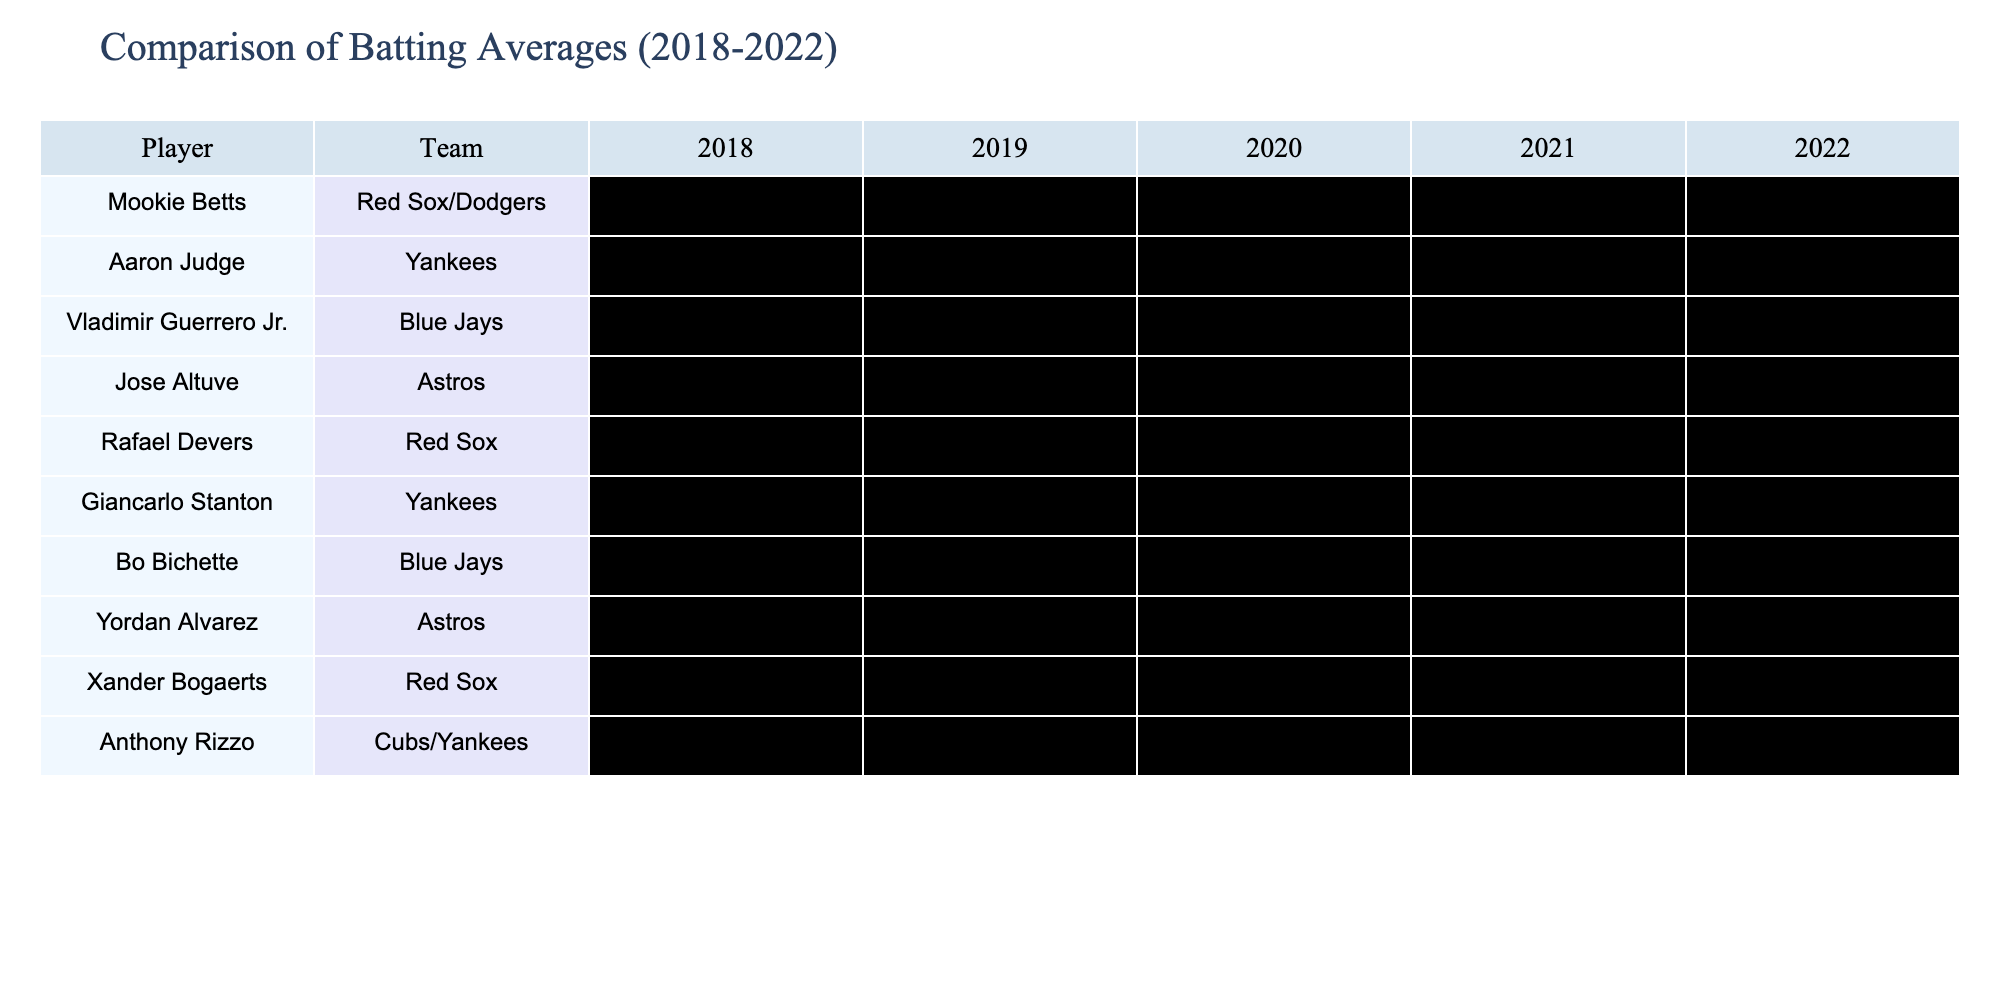What is the batting average of Mookie Betts in 2019? According to the table, Mookie Betts has a batting average of .295 in 2019.
Answer: .295 Which player had the highest batting average in 2022? Looking at the table, we can see the batting averages for each player in 2022, and Jose Altuve had the highest with .300.
Answer: .300 What was Aaron Judge's average over the last five seasons? To find Aaron Judge's average, we sum his batting averages: (.278 + .272 + .287 + .287 + .311) = 1.435. Then, we divide by 5, resulting in an average of 1.435/5 = .287.
Answer: .287 Did Giancarlo Stanton ever achieve a batting average over .300 in these five years? By reviewing Stanton's averages, they are .266, .288, .250, .273, and .211, none of which exceed .300.
Answer: No How many players had an average above .300 in 2022? Checking the table's data for 2022, we find that only two players, Jose Altuve (.300) and Xander Bogaerts (.307), had averages over .300.
Answer: 2 What was the difference in batting averages between Xander Bogaerts and Rafael Devers in 2022? Xander Bogaerts had an average of .307 while Rafael Devers had .295 in 2022. The difference is calculated as .307 - .295 = .012.
Answer: .012 Which teams' players had the highest and lowest batting averages collectively across all years? Assessing the averages, the Red Sox players (Betts, Devers, Bogaerts) performed well, while Giancarlo Stanton from the Yankees had the lowest averages. A detailed look reveals the Red Sox had higher cumulative averages than the Yankees.
Answer: Red Sox: highest, Yankees: lowest Who improved their batting average the most from 2018 to 2022? Comparing the averages from 2018 to 2022 for all players, we find Yordan Alvarez improved from .000 to .306, showing a clear improvement of .306 points.
Answer: Yordan Alvarez What is the average batting average of the Blue Jays players over the five years? The Blue Jays players' averages are: Vladimir Guerrero Jr. (.272, .272, .311, .274, .274) and Bo Bichette (.250, .311, .301, .298, .290). Calculating these gives (.272 + .272 + .311 + .274 + .274 + .250 + .311 + .301 + .298 + .290) = 2.883, divided by 10 gives an average of .288.
Answer: .288 Was there a season where all players performed better than their 2022 averages? Assessing the table, there isn't an instance where every player's average from previous seasons exceeds their 2022 averages at the same time. Some players had their best averages earlier.
Answer: No 